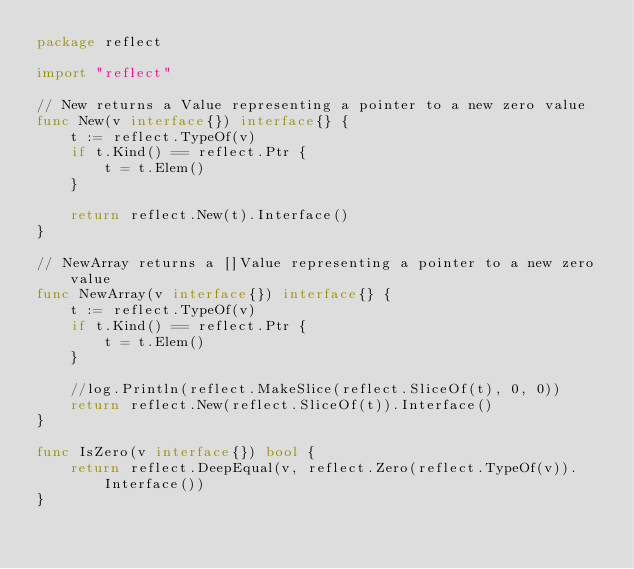Convert code to text. <code><loc_0><loc_0><loc_500><loc_500><_Go_>package reflect

import "reflect"

// New returns a Value representing a pointer to a new zero value
func New(v interface{}) interface{} {
	t := reflect.TypeOf(v)
	if t.Kind() == reflect.Ptr {
		t = t.Elem()
	}

	return reflect.New(t).Interface()
}

// NewArray returns a []Value representing a pointer to a new zero value
func NewArray(v interface{}) interface{} {
	t := reflect.TypeOf(v)
	if t.Kind() == reflect.Ptr {
		t = t.Elem()
	}

	//log.Println(reflect.MakeSlice(reflect.SliceOf(t), 0, 0))
	return reflect.New(reflect.SliceOf(t)).Interface()
}

func IsZero(v interface{}) bool {
	return reflect.DeepEqual(v, reflect.Zero(reflect.TypeOf(v)).Interface())
}
</code> 